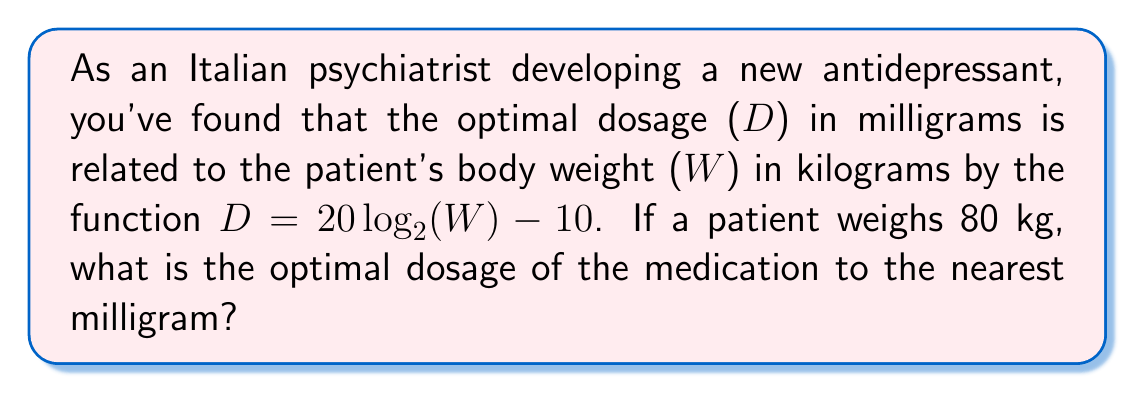Teach me how to tackle this problem. Let's approach this step-by-step:

1) We are given the function: $D = 20 \log_2(W) - 10$

2) We need to find D when W = 80 kg

3) Let's substitute W = 80 into the equation:
   $D = 20 \log_2(80) - 10$

4) Now, let's evaluate $\log_2(80)$:
   $80 = 2^x$
   $x = \log_2(80) \approx 6.321928$

5) Substituting this back into our equation:
   $D = 20(6.321928) - 10$

6) Let's calculate:
   $D = 126.43856 - 10 = 116.43856$

7) Rounding to the nearest milligram:
   $D \approx 116$ mg
Answer: 116 mg 